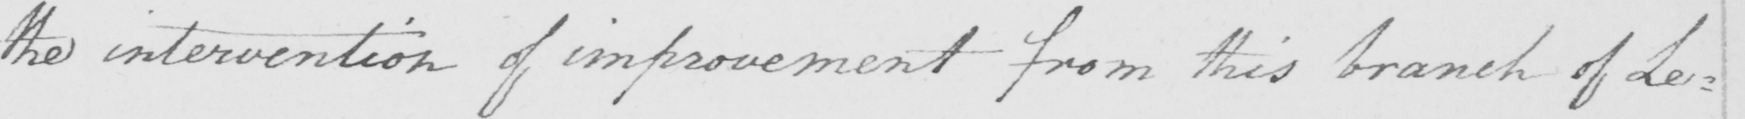What does this handwritten line say? the intervention of improvement from this branch of Le= 